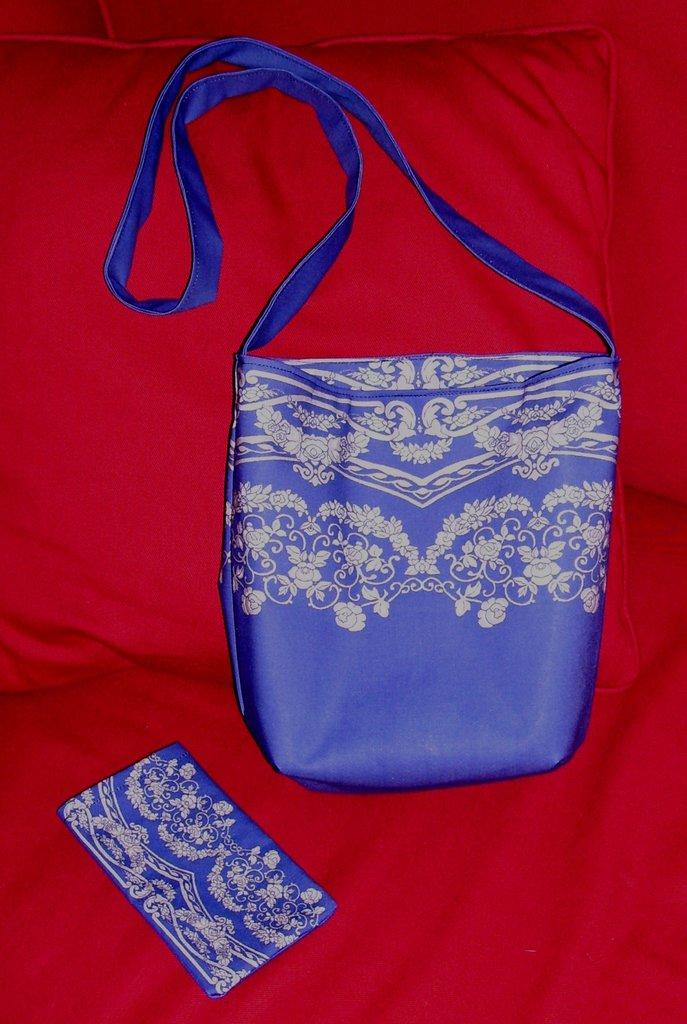What object is present in the image that can be used for carrying items? The image contains a bag. What is the color of the bag? The bag is blue in color. Is there any design on the bag? Yes, the bag has a printed design. What is located behind the bag in the image? The backside of the bag is a red pillow. What is the color of the cloth of the bag? The cloth of the bag is red in color. What type of knee support can be seen in the image? There is no knee support present in the image. 